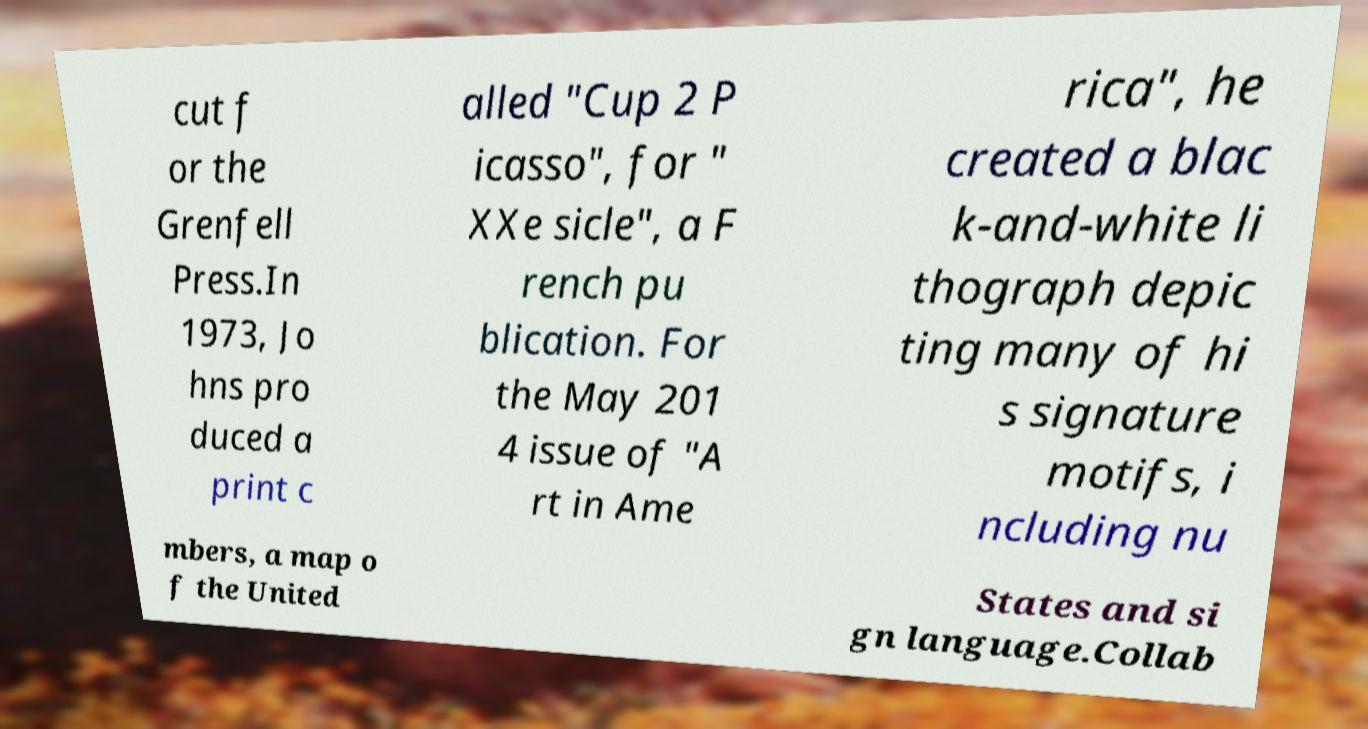Can you read and provide the text displayed in the image?This photo seems to have some interesting text. Can you extract and type it out for me? cut f or the Grenfell Press.In 1973, Jo hns pro duced a print c alled "Cup 2 P icasso", for " XXe sicle", a F rench pu blication. For the May 201 4 issue of "A rt in Ame rica", he created a blac k-and-white li thograph depic ting many of hi s signature motifs, i ncluding nu mbers, a map o f the United States and si gn language.Collab 